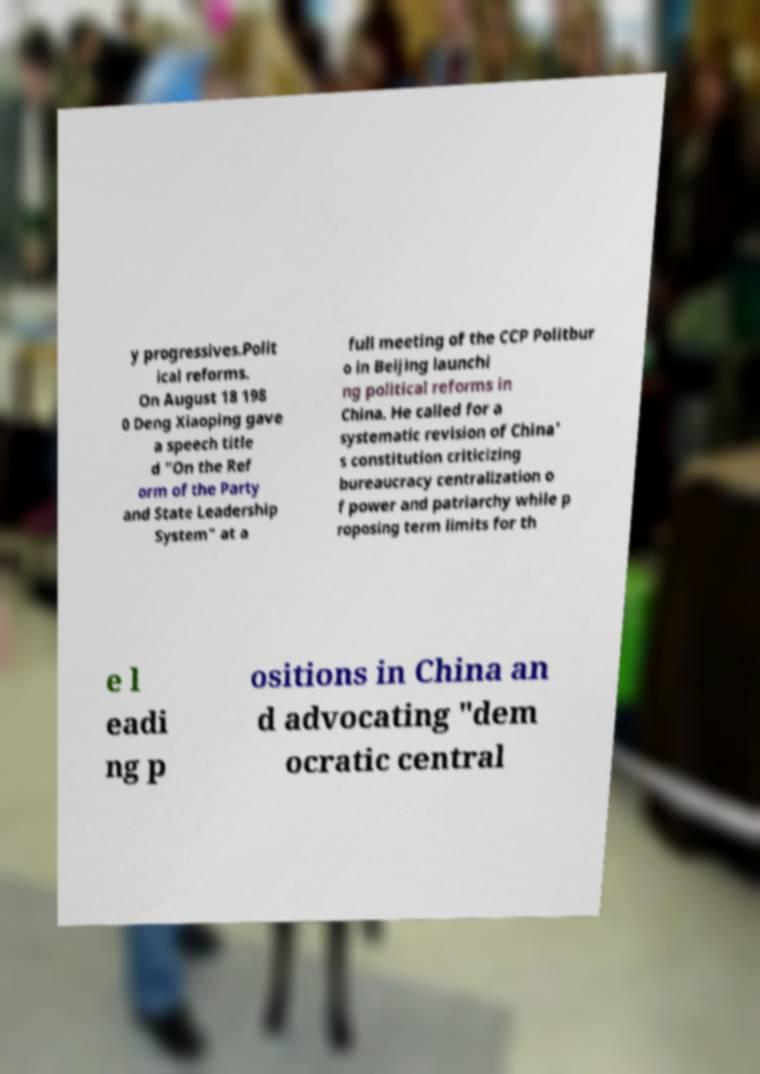Can you accurately transcribe the text from the provided image for me? y progressives.Polit ical reforms. On August 18 198 0 Deng Xiaoping gave a speech title d "On the Ref orm of the Party and State Leadership System" at a full meeting of the CCP Politbur o in Beijing launchi ng political reforms in China. He called for a systematic revision of China' s constitution criticizing bureaucracy centralization o f power and patriarchy while p roposing term limits for th e l eadi ng p ositions in China an d advocating "dem ocratic central 